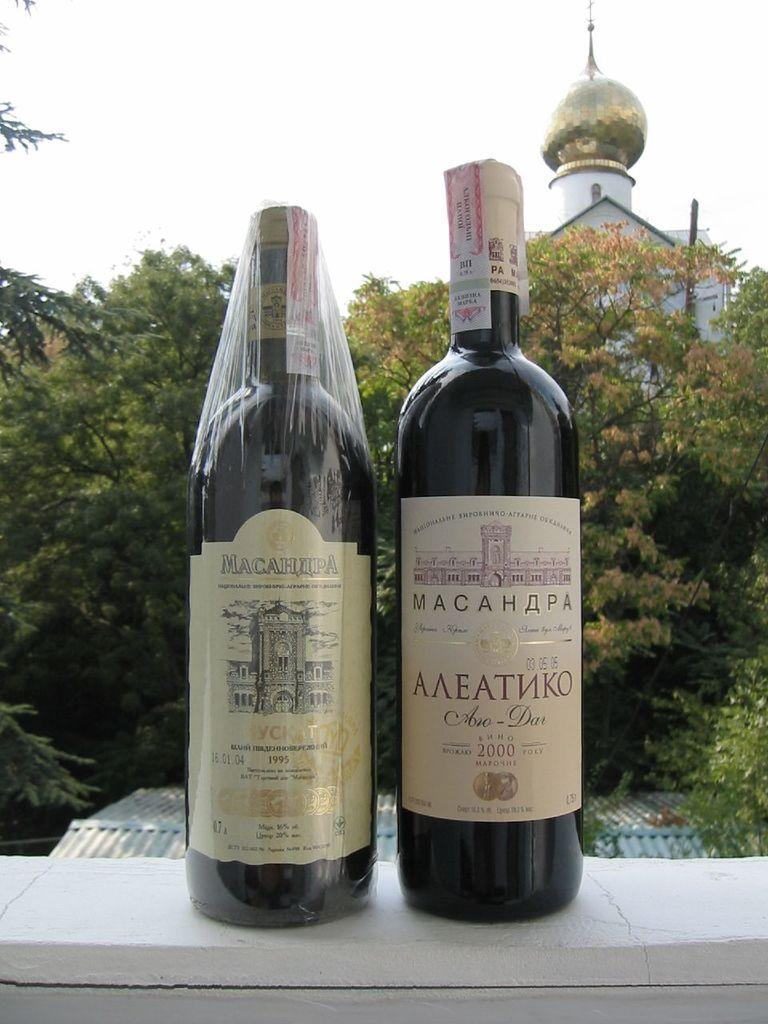<image>
Describe the image concisely. Macahapa wine bottle right next to another Macahapa bottle. 